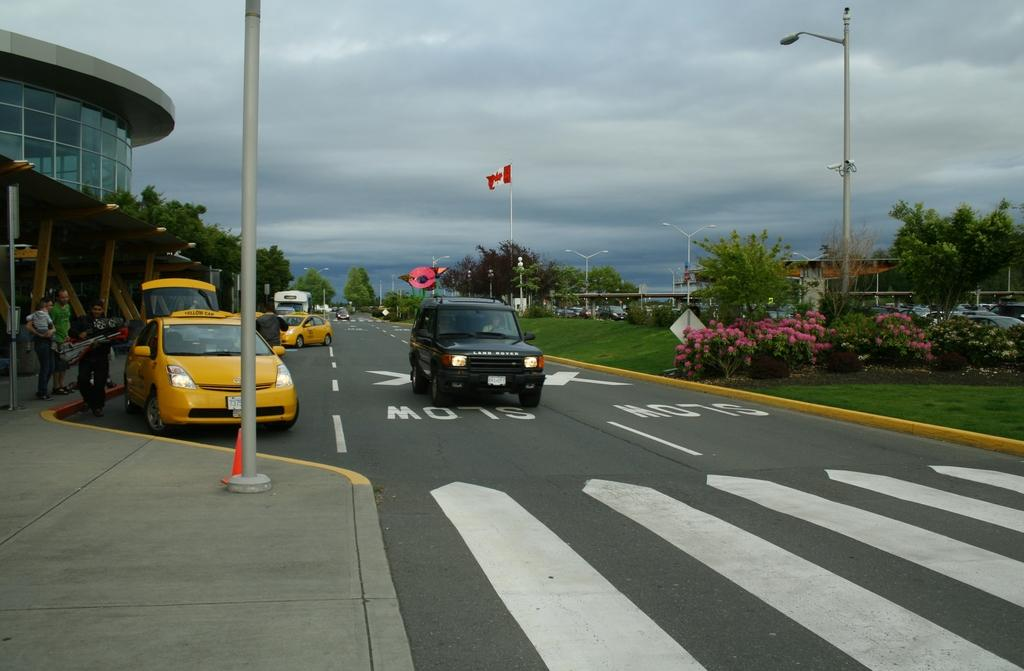<image>
Relay a brief, clear account of the picture shown. The writing on the street warns drivers to drive slow. 